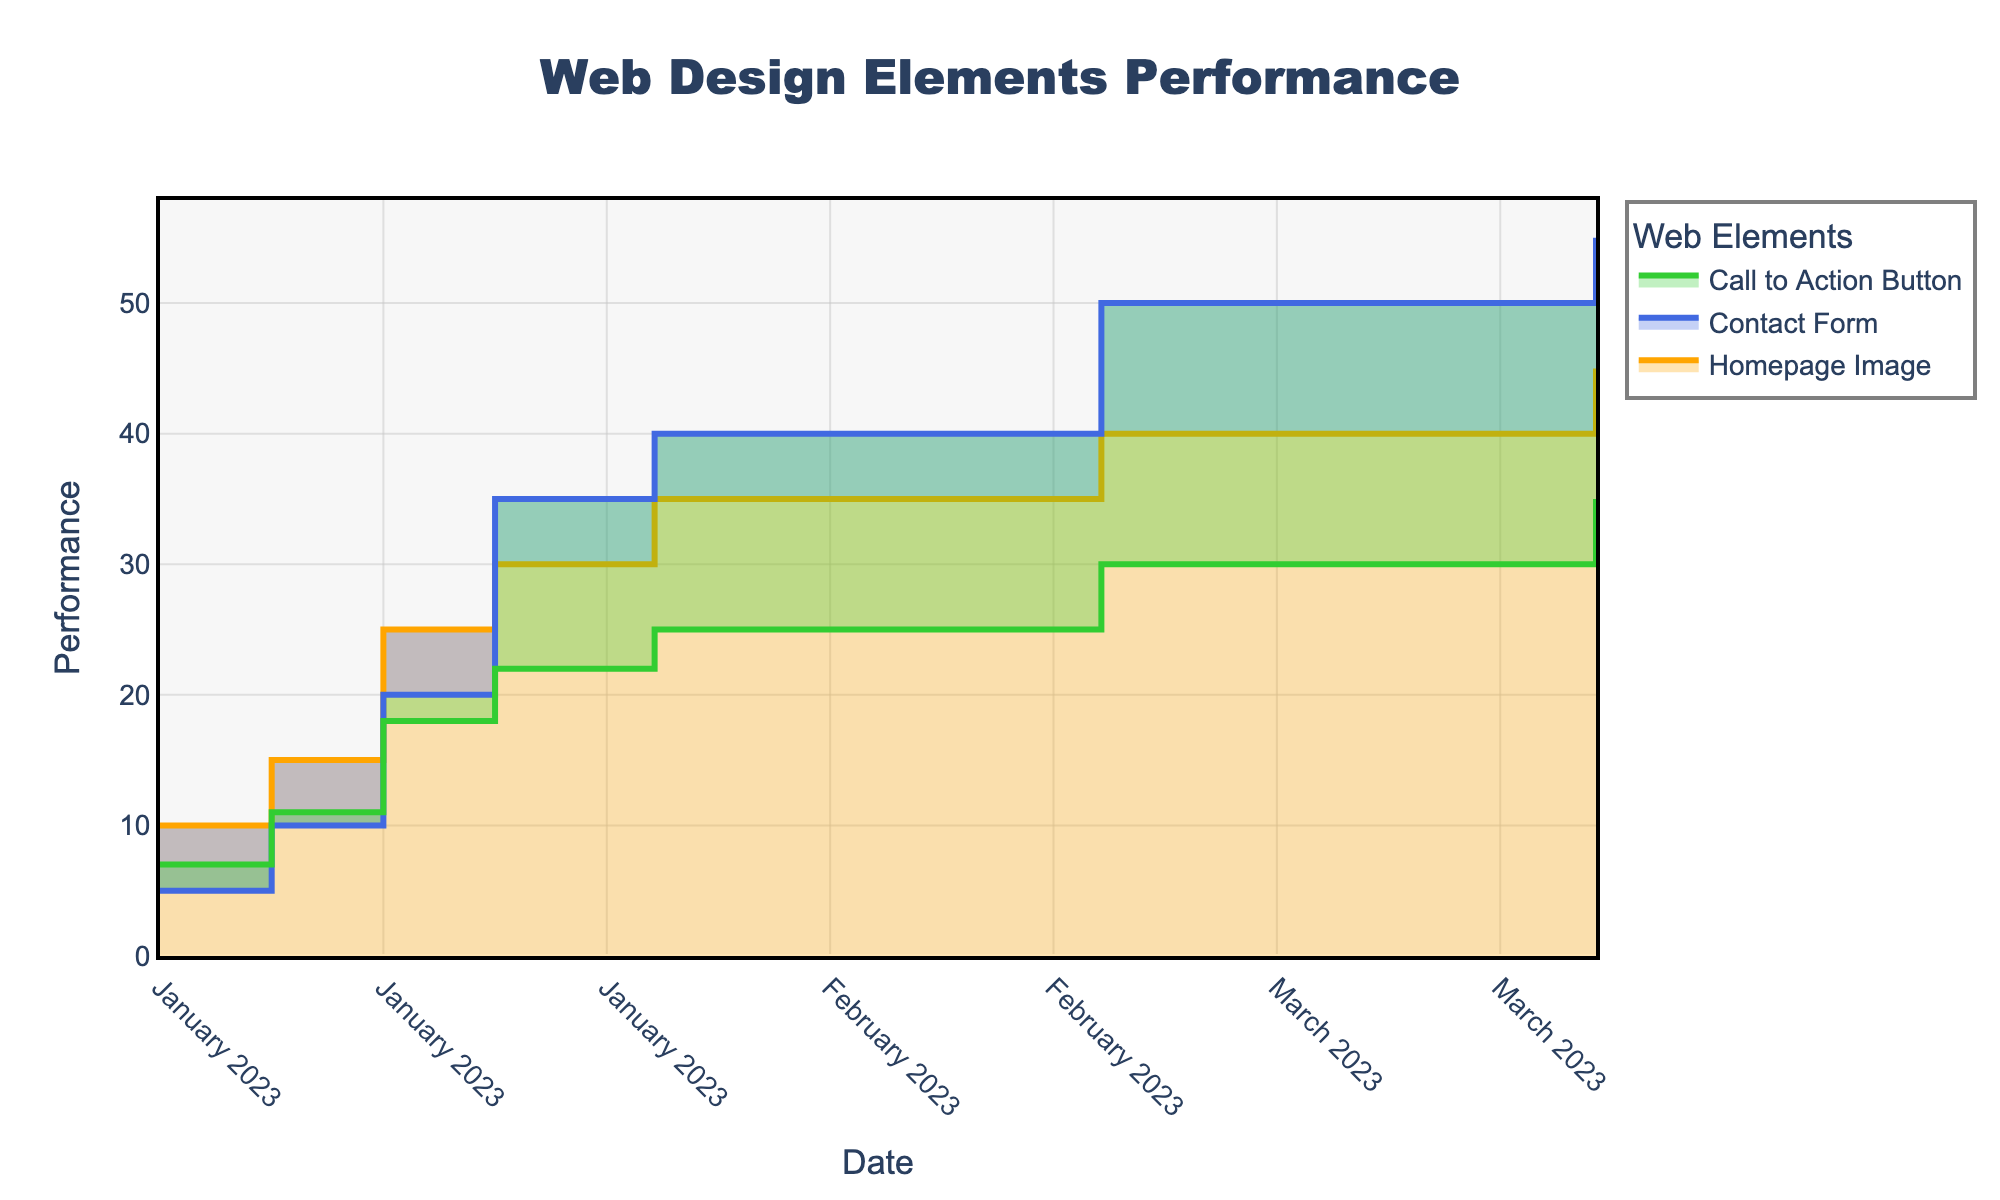What is the title of the chart? The title is located at the top of the chart, centered. It reads 'Web Design Elements Performance'.
Answer: Web Design Elements Performance Which web design element had the highest performance on January 22, 2023? The chart shows that on January 22, 2023, the Contact Form had the highest performance among the elements at a value of 35.
Answer: Contact Form How does the performance of the Call to Action Button compare with the Homepage Image on February 1, 2023? On February 1, 2023, the Call to Action Button’s performance was 25, while the Homepage Image’s performance was 35. Thus, the Homepage Image performed better by 10 units.
Answer: Homepage Image What is the performance difference between the Call to Action Button and the Contact Form on April 1, 2023? On April 1, 2023, the performance of the Call to Action Button is 35 and the Contact Form is 55. So, the difference is 55 - 35 = 20 units.
Answer: 20 Which web design element showed the most significant improvement from January 1, 2023, to April 1, 2023? By examining the start and end dates, the Contact Form increased from 5 to 55, which is an improvement of 50 units, the largest among the elements.
Answer: Contact Form How many data points are there for the Homepage Image in the chart? The Homepage Image data series has points on January 1, 8, 15, 22, February 1, March 1, and April 1, 2023. This totals 7 data points.
Answer: 7 By how much did the Contact Form's performance increase from March 1, 2023, to April 1, 2023? On March 1, 2023, the performance was 50, and on April 1, 2023, it was 55. The increase is 55 - 50 = 5 units.
Answer: 5 Which element had the least performance increase from January 1 to February 1, 2023? Considering performance on January 1 and February 1— the Homepage Image from 10 to 35 (25 units), Contact Form from 5 to 40 (35 units), and Call to Action Button from 7 to 25 (18 units)— the Call to Action Button had the least increase of 18 units.
Answer: Call to Action Button 